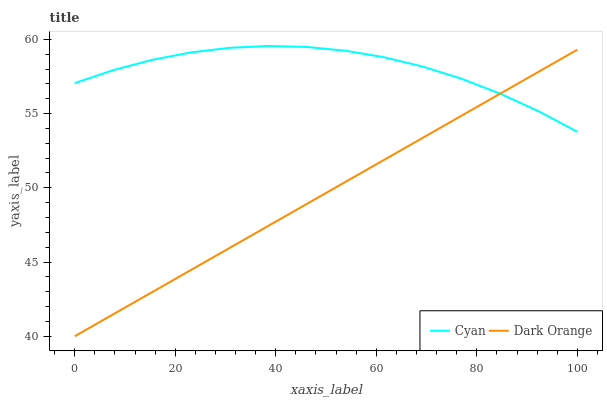Does Dark Orange have the minimum area under the curve?
Answer yes or no. Yes. Does Cyan have the maximum area under the curve?
Answer yes or no. Yes. Does Dark Orange have the maximum area under the curve?
Answer yes or no. No. Is Dark Orange the smoothest?
Answer yes or no. Yes. Is Cyan the roughest?
Answer yes or no. Yes. Is Dark Orange the roughest?
Answer yes or no. No. Does Dark Orange have the lowest value?
Answer yes or no. Yes. Does Cyan have the highest value?
Answer yes or no. Yes. Does Dark Orange have the highest value?
Answer yes or no. No. Does Dark Orange intersect Cyan?
Answer yes or no. Yes. Is Dark Orange less than Cyan?
Answer yes or no. No. Is Dark Orange greater than Cyan?
Answer yes or no. No. 